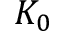<formula> <loc_0><loc_0><loc_500><loc_500>K _ { 0 }</formula> 